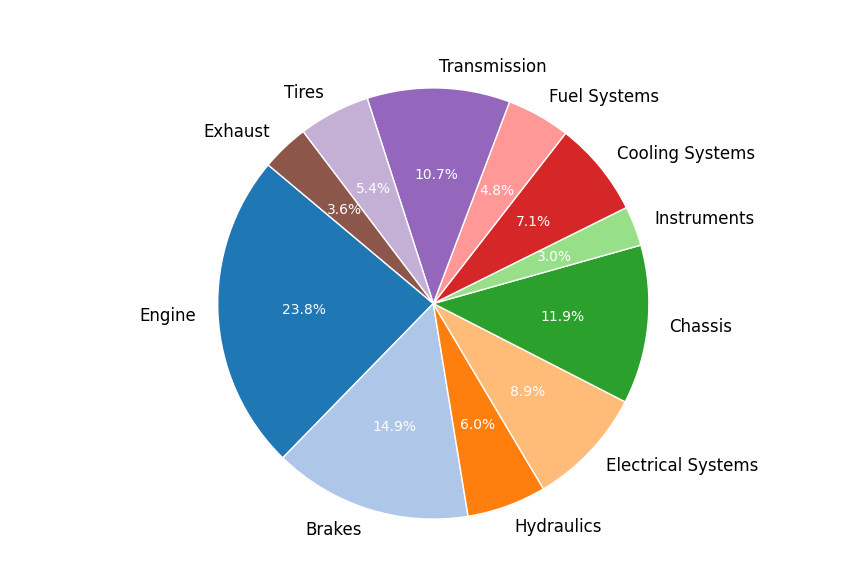What's the largest cost component for the repairs? To find the largest cost component, we look at the slice of the pie chart representing the highest percentage of the total cost. The ‘Engine’ component represents the largest slice.
Answer: Engine What percentage of the total repair costs does the Electrical Systems component constitute? Find the Electrical Systems slice on the pie chart and look at the percentage displayed on or next to it. The Electrical Systems component constitutes 10% of the total repair costs.
Answer: 10% Which two components together make up the smallest combined percentage of the total repair costs? Look for the two smallest slices on the pie chart and add their percentages. The Instruments (5%) and Exhaust (6%) components together make up the smallest combined percentage of 5% + 6% = 11%.
Answer: Instruments and Exhaust Is the cost of Chassis repairs greater than the combined cost of Transmission and Tires repairs? Identify the slices for Chassis, Transmission, and Tires, then sum the percentages of Transmission and Tires and compare with Chassis. Chassis is 20% while Transmission and Tires together are 18% + 9% = 27%. The cost of Chassis is less.
Answer: No What is the difference in cost percentage between the Engine and Brakes? Find the Engine and Brakes slices and subtract the percentage of Brakes from Engine. The Engine is at 32%, and the Brakes are at 20%, so the difference is 32% - 20% = 12%.
Answer: 12% How much greater is the cost percentage for the Engine repairs compared to Electrical Systems? Find the slices for Engine and Electrical Systems and subtract Electrical Systems from Engine. Engine is 32% while Electrical Systems is 10%, so the difference is 32% - 10% = 22%.
Answer: 22% Are the Hydraulics and Exhaust components combined cost greater than the Engine component? Sum the percentages of Hydraulics and Exhaust and compare them with the Engine. Hydraulics is 8% and Exhaust is 5%, so combined they are 8% + 5% = 13%, which is less than the Engine’s 32%.
Answer: No What portion of the pie chart does the combination of Brakes, Electrical Systems, and Cooling Systems constitute? Add the percentages of Brakes, Electrical Systems, and Cooling Systems. Brakes is 20%, Electrical Systems is 10%, and Cooling Systems is 9%, so combined they are 20% + 10% + 9% = 39%.
Answer: 39% If the costs for Fuel Systems and Instruments were combined, where would it rank in terms of size compared to other individual components? Sum the percentages of Fuel Systems and Instruments, then compare with other individual components. Fuel Systems is 6.4% and Instruments is 4%, so combined they are 10.4%. This would rank approximately between Electrical Systems (10%) and Hydraulics (8%).
Answer: Between Electrical Systems and Hydraulics 